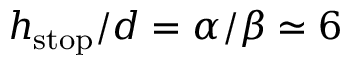<formula> <loc_0><loc_0><loc_500><loc_500>h _ { s t o p } / d = \alpha / \beta \simeq 6</formula> 